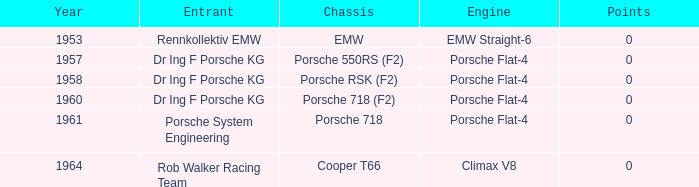Which engine did dr ing f porsche kg use with the porsche rsk (f2) chassis? Porsche Flat-4. 